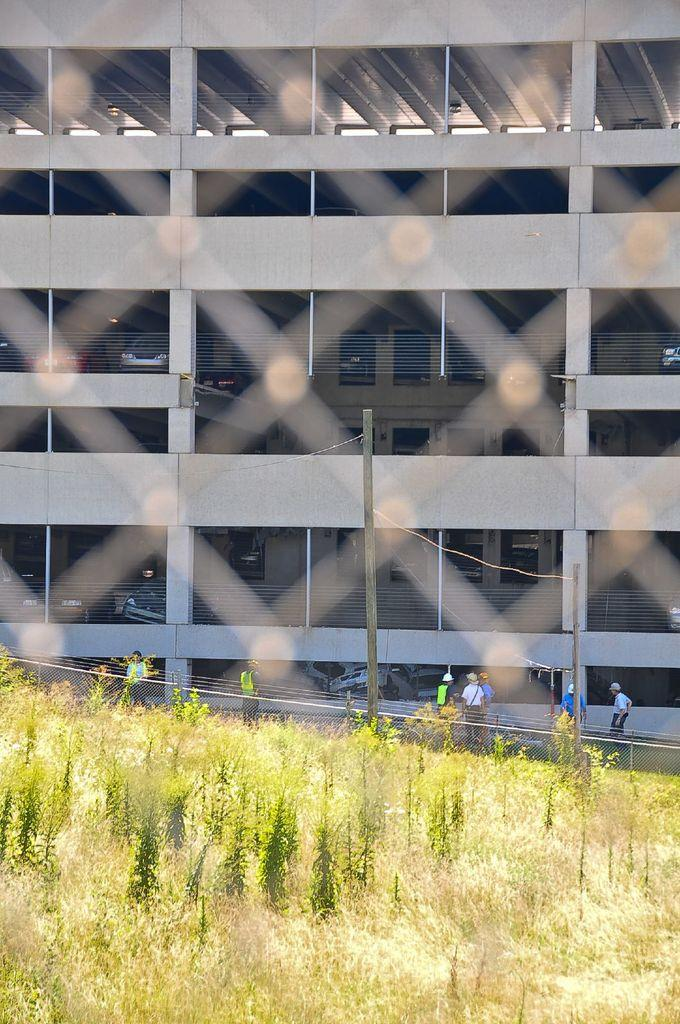What type of structure is visible in the image? There is a building in the image. What can be seen near the building? There are cars parked in the image. Are there any people present in the image? Yes, there are people standing in the image. What type of vegetation is on the ground in the image? There are plants on the ground in the image. Can you see any mice using the apparatus in the image? There are no mice or apparatus present in the image. What type of sail is visible in the image? There is no sail present in the image. 